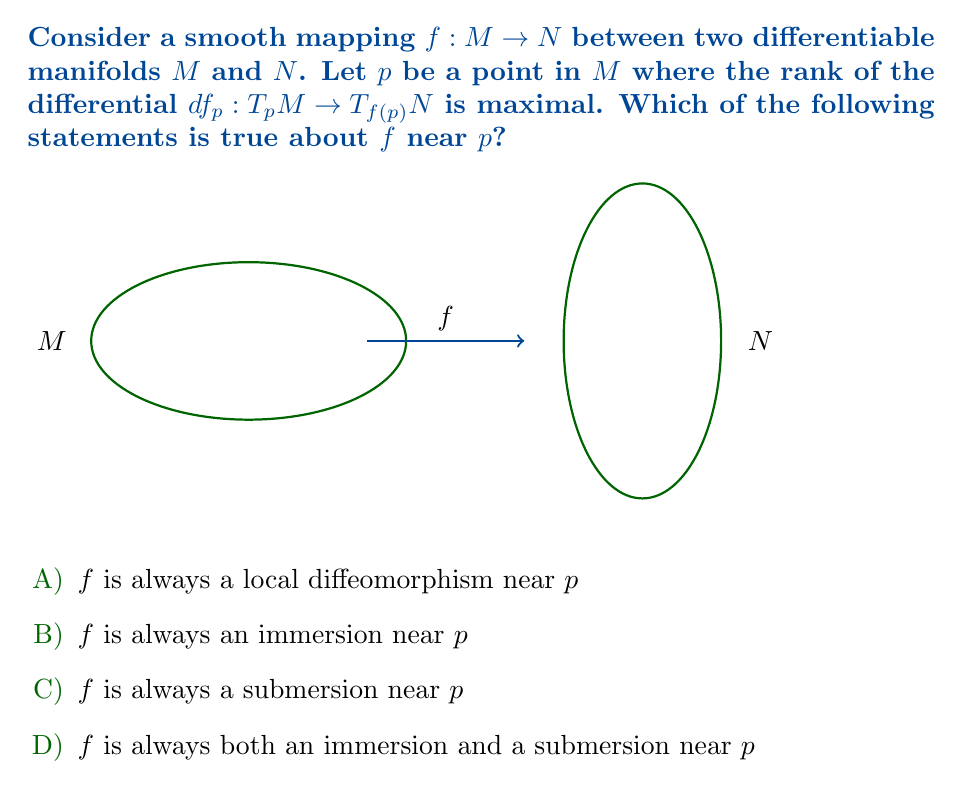Give your solution to this math problem. Let's approach this step-by-step:

1) First, recall that the rank of $df_p$ is the dimension of its image, which is at most $\min(\dim M, \dim N)$.

2) When we say the rank is maximal at $p$, we mean it equals $\min(\dim M, \dim N)$.

3) Now, let's consider each option:

   A) For $f$ to be a local diffeomorphism, we need $\dim M = \dim N$ and $df_p$ to be invertible. This is not guaranteed by the given information.

   B) An immersion requires that $df_p$ is injective. This is guaranteed when $\dim M \leq \dim N$ and the rank is maximal.

   C) A submersion requires that $df_p$ is surjective. This is guaranteed when $\dim M \geq \dim N$ and the rank is maximal.

   D) For $f$ to be both an immersion and a submersion, we would need $\dim M = \dim N$ and $df_p$ to be invertible, which is not guaranteed.

4) Therefore, we can conclude that $f$ is always an immersion near $p$ when $\dim M \leq \dim N$, and always a submersion near $p$ when $\dim M \geq \dim N$.

5) The only statement that is always true, regardless of the relative dimensions of $M$ and $N$, is that $f$ is an immersion near $p$.

This result, known as the Rank Theorem, is a fundamental property of smooth mappings between manifolds and has important applications in differential geometry and topology.
Answer: B) $f$ is always an immersion near $p$ 